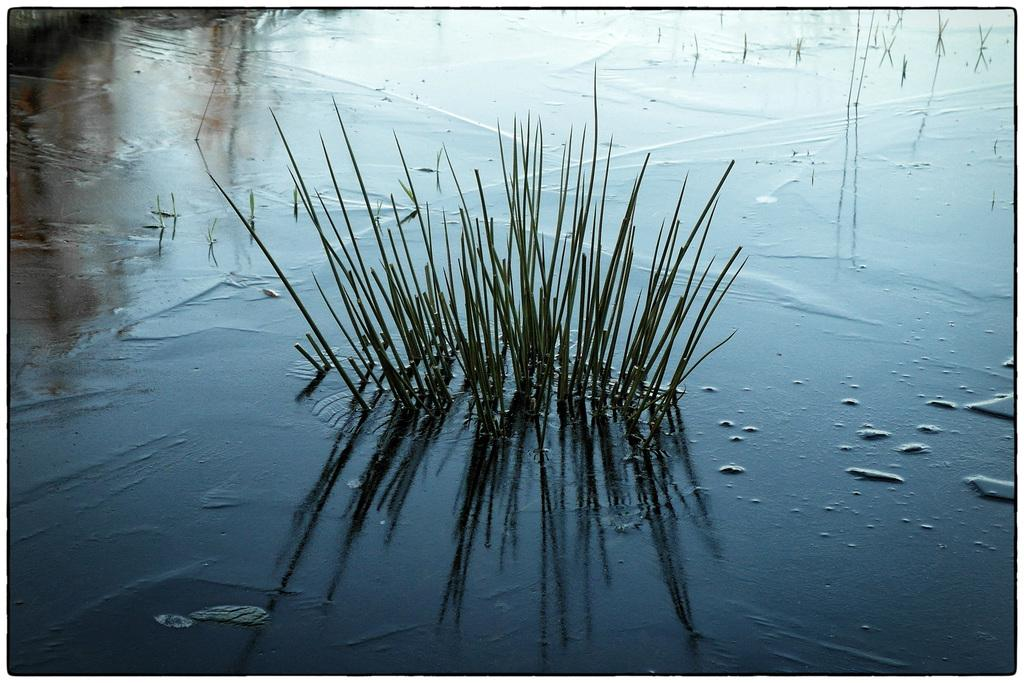What is present in the image? There is water in the image. What can be found within the water in the image? There are plants in the water. What type of furniture can be seen floating in the water in the image? There is no furniture present in the image; it only features water and plants. 